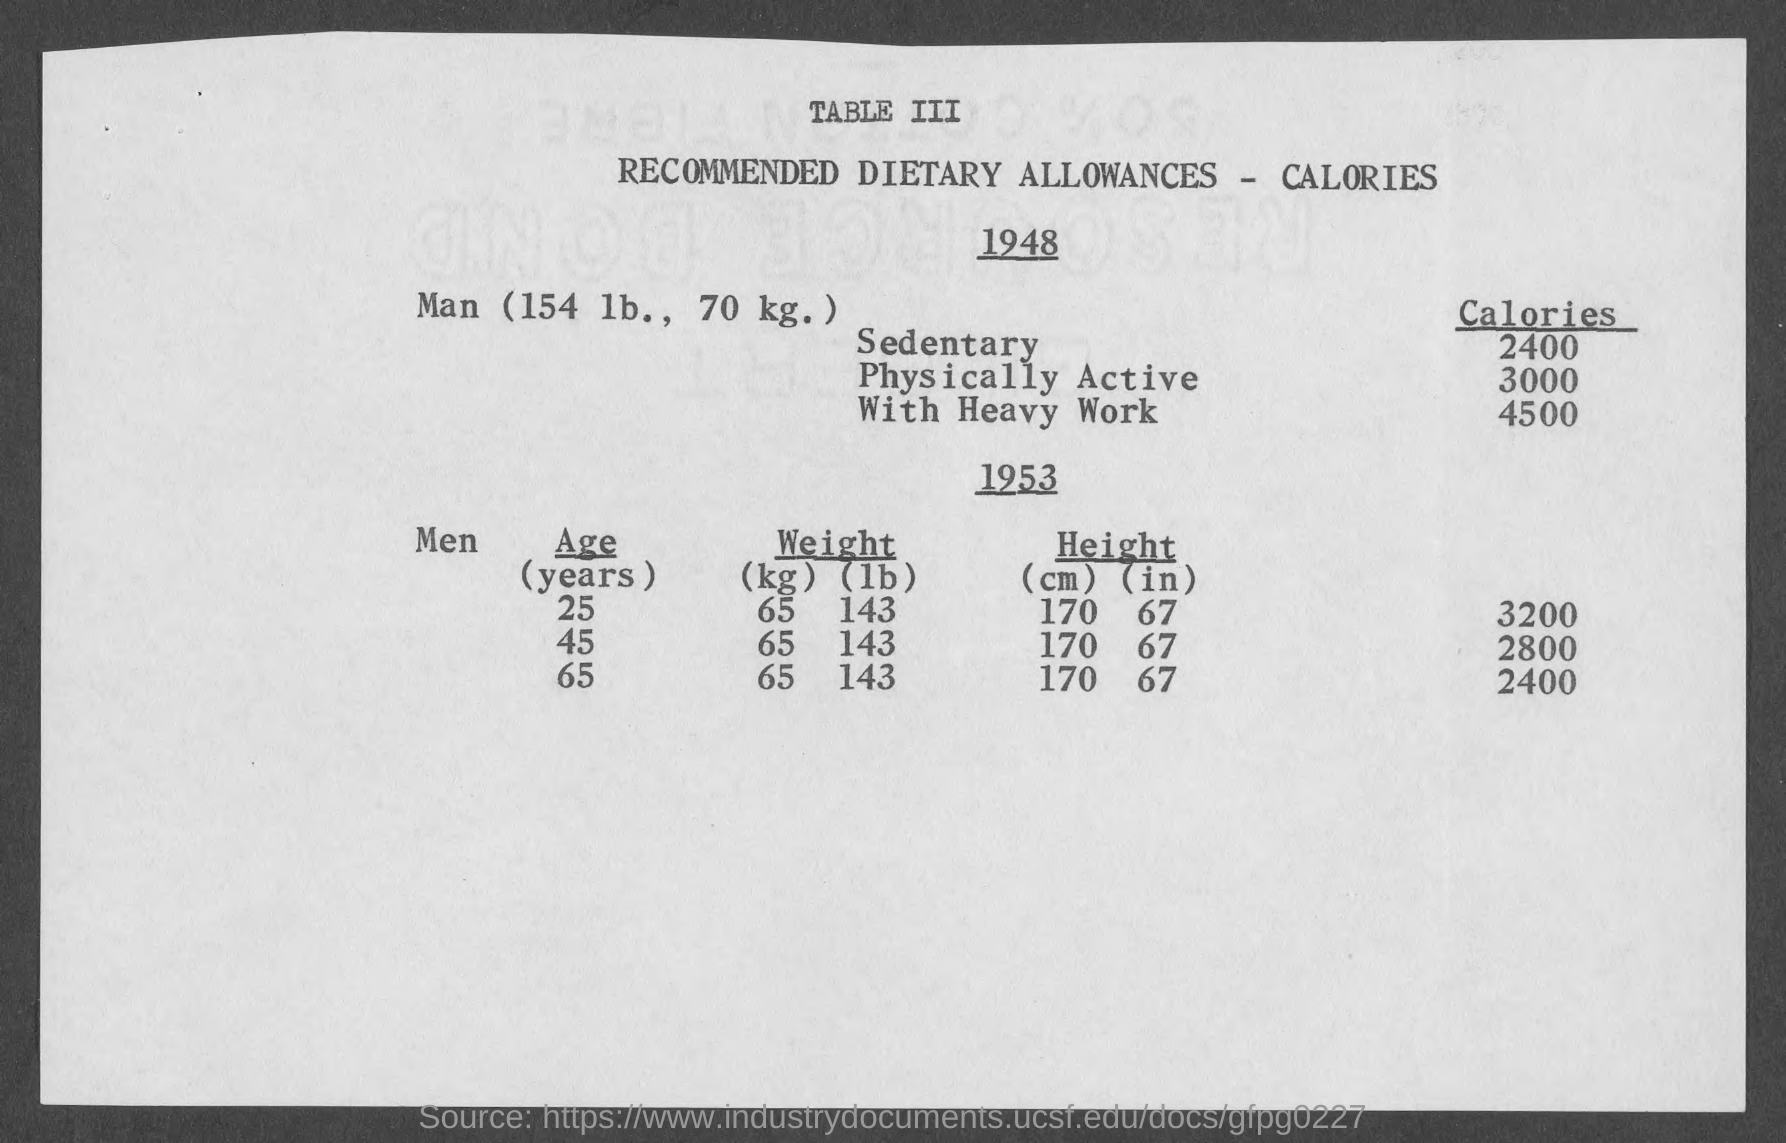Point out several critical features in this image. It is recommended that physically active men consume approximately 3000 calories per day to meet their energy needs. What must be the weight of men at 25 years in kilograms? The weight of men at 25 years is 65 kilograms. It is recommended that sedentary individuals consume approximately 2400 calories per day. The title of Table III is 'Recommended Dietary Allowances - Calories,' which provides the recommended daily intake of calories for different age and sex groups. It is recommended that a man who engages in heavy physical work consume approximately 4500 calories per day to meet their energy needs. 